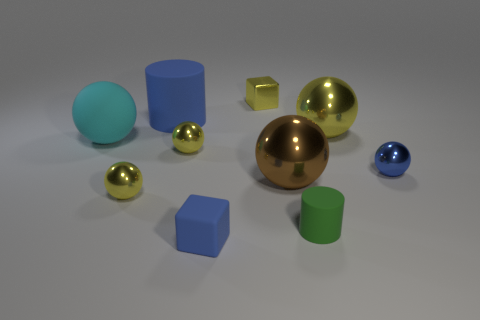Subtract all purple cylinders. How many yellow balls are left? 3 Subtract all cyan balls. How many balls are left? 5 Subtract all big cyan matte spheres. How many spheres are left? 5 Subtract all blue spheres. Subtract all purple cylinders. How many spheres are left? 5 Subtract all cylinders. How many objects are left? 8 Subtract 0 gray cylinders. How many objects are left? 10 Subtract all large things. Subtract all blue cylinders. How many objects are left? 5 Add 3 small blue rubber things. How many small blue rubber things are left? 4 Add 8 large blue objects. How many large blue objects exist? 9 